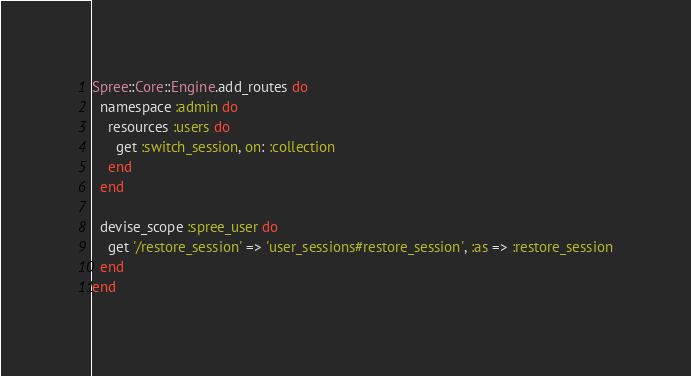Convert code to text. <code><loc_0><loc_0><loc_500><loc_500><_Ruby_>Spree::Core::Engine.add_routes do
  namespace :admin do
    resources :users do
      get :switch_session, on: :collection
    end
  end

  devise_scope :spree_user do
    get '/restore_session' => 'user_sessions#restore_session', :as => :restore_session
  end
end
</code> 